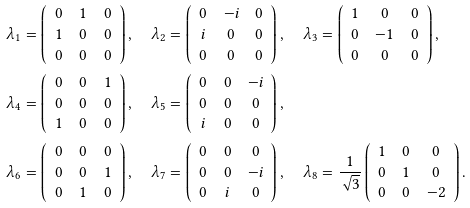Convert formula to latex. <formula><loc_0><loc_0><loc_500><loc_500>\lambda _ { 1 } & = \left ( \begin{array} { c c c } 0 & 1 & 0 \\ 1 & 0 & 0 \\ 0 & 0 & 0 \end{array} \right ) , \quad \lambda _ { 2 } = \left ( \begin{array} { c c c } 0 & - i & 0 \\ i & 0 & 0 \\ 0 & 0 & 0 \end{array} \right ) , \quad \lambda _ { 3 } = \left ( \begin{array} { c c c } 1 & 0 & 0 \\ 0 & - 1 & 0 \\ 0 & 0 & 0 \end{array} \right ) , \\ \lambda _ { 4 } & = \left ( \begin{array} { c c c } 0 & 0 & 1 \\ 0 & 0 & 0 \\ 1 & 0 & 0 \end{array} \right ) , \quad \lambda _ { 5 } = \left ( \begin{array} { c c c } 0 & 0 & - i \\ 0 & 0 & 0 \\ i & 0 & 0 \end{array} \right ) , \\ \lambda _ { 6 } & = \left ( \begin{array} { c c c } 0 & 0 & 0 \\ 0 & 0 & 1 \\ 0 & 1 & 0 \end{array} \right ) , \quad \lambda _ { 7 } = \left ( \begin{array} { c c c } 0 & 0 & 0 \\ 0 & 0 & - i \\ 0 & i & 0 \end{array} \right ) , \quad \lambda _ { 8 } = \frac { 1 } { \sqrt { 3 } } \left ( \begin{array} { c c c } 1 & 0 & 0 \\ 0 & 1 & 0 \\ 0 & 0 & - 2 \end{array} \right ) .</formula> 